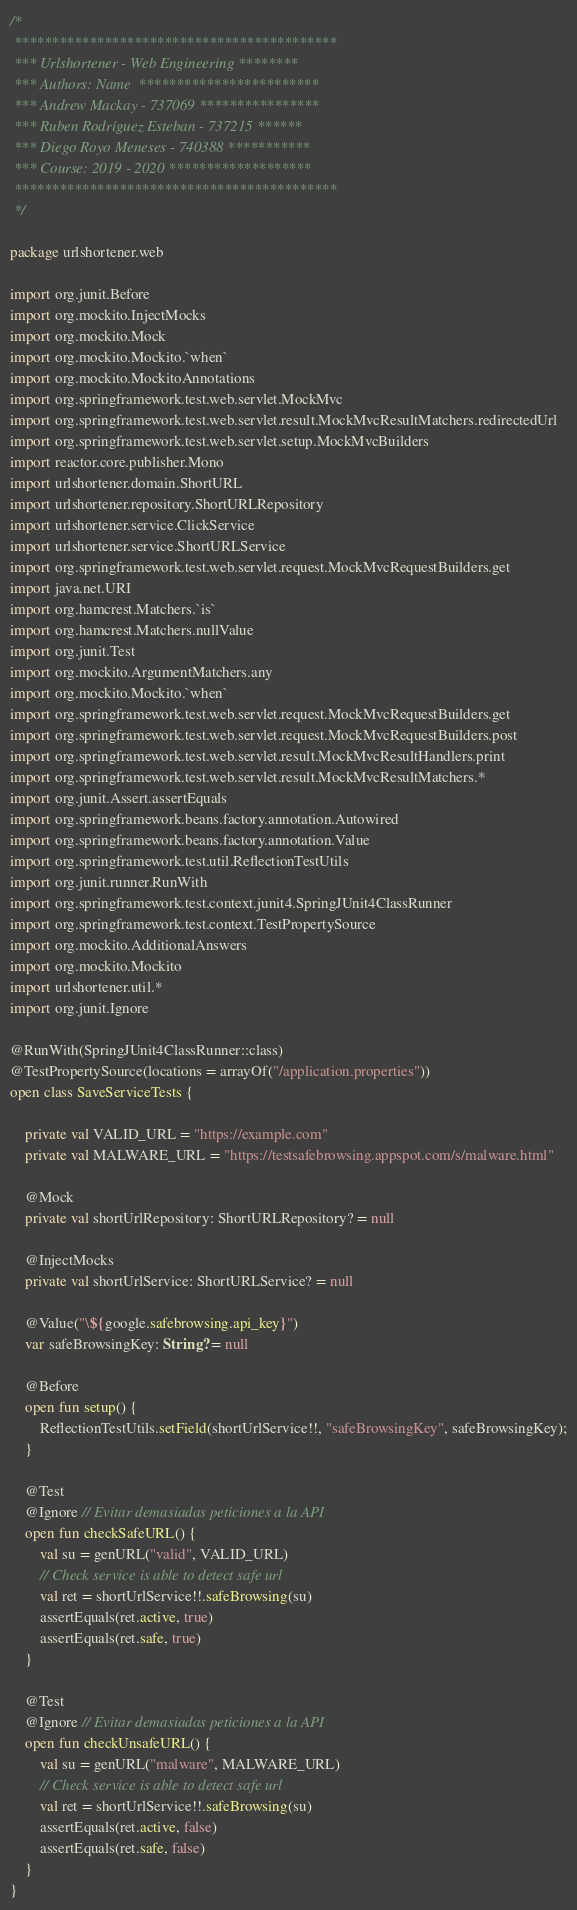<code> <loc_0><loc_0><loc_500><loc_500><_Kotlin_>/*
 *******************************************
 *** Urlshortener - Web Engineering ********
 *** Authors: Name  ************************
 *** Andrew Mackay - 737069 ****************
 *** Ruben Rodríguez Esteban - 737215 ******
 *** Diego Royo Meneses - 740388 ***********
 *** Course: 2019 - 2020 *******************
 *******************************************
 */

package urlshortener.web

import org.junit.Before
import org.mockito.InjectMocks
import org.mockito.Mock
import org.mockito.Mockito.`when`
import org.mockito.MockitoAnnotations
import org.springframework.test.web.servlet.MockMvc
import org.springframework.test.web.servlet.result.MockMvcResultMatchers.redirectedUrl
import org.springframework.test.web.servlet.setup.MockMvcBuilders
import reactor.core.publisher.Mono
import urlshortener.domain.ShortURL
import urlshortener.repository.ShortURLRepository
import urlshortener.service.ClickService
import urlshortener.service.ShortURLService
import org.springframework.test.web.servlet.request.MockMvcRequestBuilders.get
import java.net.URI
import org.hamcrest.Matchers.`is`
import org.hamcrest.Matchers.nullValue
import org.junit.Test
import org.mockito.ArgumentMatchers.any
import org.mockito.Mockito.`when`
import org.springframework.test.web.servlet.request.MockMvcRequestBuilders.get
import org.springframework.test.web.servlet.request.MockMvcRequestBuilders.post
import org.springframework.test.web.servlet.result.MockMvcResultHandlers.print
import org.springframework.test.web.servlet.result.MockMvcResultMatchers.*
import org.junit.Assert.assertEquals
import org.springframework.beans.factory.annotation.Autowired
import org.springframework.beans.factory.annotation.Value
import org.springframework.test.util.ReflectionTestUtils
import org.junit.runner.RunWith
import org.springframework.test.context.junit4.SpringJUnit4ClassRunner
import org.springframework.test.context.TestPropertySource
import org.mockito.AdditionalAnswers
import org.mockito.Mockito
import urlshortener.util.*
import org.junit.Ignore

@RunWith(SpringJUnit4ClassRunner::class)
@TestPropertySource(locations = arrayOf("/application.properties"))
open class SaveServiceTests {
    
    private val VALID_URL = "https://example.com"
    private val MALWARE_URL = "https://testsafebrowsing.appspot.com/s/malware.html"

    @Mock
    private val shortUrlRepository: ShortURLRepository? = null

    @InjectMocks
    private val shortUrlService: ShortURLService? = null

    @Value("\${google.safebrowsing.api_key}")
    var safeBrowsingKey: String? = null

    @Before
    open fun setup() {
        ReflectionTestUtils.setField(shortUrlService!!, "safeBrowsingKey", safeBrowsingKey);
    }

    @Test
    @Ignore // Evitar demasiadas peticiones a la API
    open fun checkSafeURL() {
        val su = genURL("valid", VALID_URL)
        // Check service is able to detect safe url
        val ret = shortUrlService!!.safeBrowsing(su)
        assertEquals(ret.active, true)
        assertEquals(ret.safe, true)
    }

    @Test
    @Ignore // Evitar demasiadas peticiones a la API
    open fun checkUnsafeURL() {
        val su = genURL("malware", MALWARE_URL)
        // Check service is able to detect safe url
        val ret = shortUrlService!!.safeBrowsing(su)
        assertEquals(ret.active, false)
        assertEquals(ret.safe, false)
    }
}</code> 